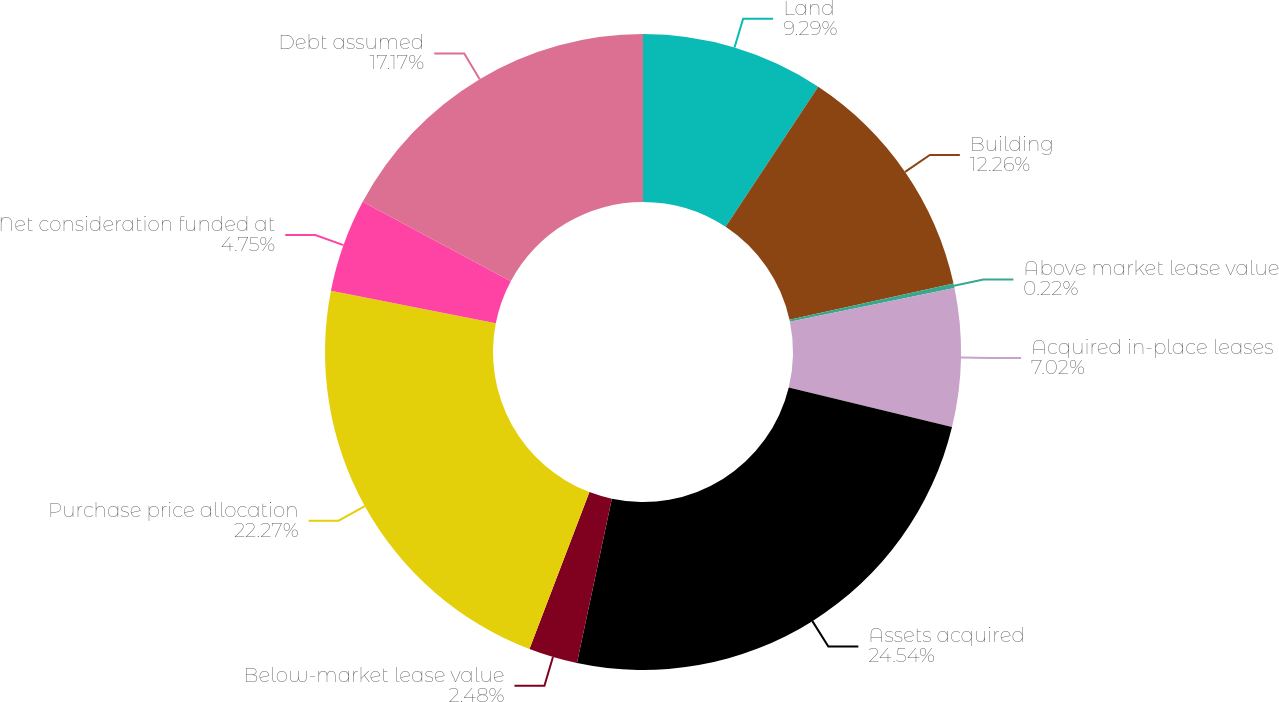Convert chart. <chart><loc_0><loc_0><loc_500><loc_500><pie_chart><fcel>Land<fcel>Building<fcel>Above market lease value<fcel>Acquired in-place leases<fcel>Assets acquired<fcel>Below-market lease value<fcel>Purchase price allocation<fcel>Net consideration funded at<fcel>Debt assumed<nl><fcel>9.29%<fcel>12.26%<fcel>0.22%<fcel>7.02%<fcel>24.54%<fcel>2.48%<fcel>22.27%<fcel>4.75%<fcel>17.17%<nl></chart> 